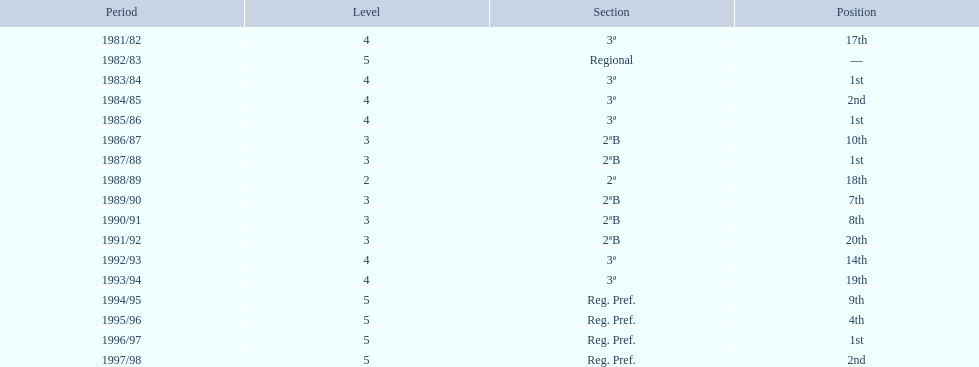In what years did the team finish 17th or worse? 1981/82, 1988/89, 1991/92, 1993/94. Of those, in which year the team finish worse? 1991/92. 